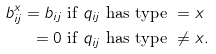<formula> <loc_0><loc_0><loc_500><loc_500>b ^ { x } _ { i j } = b _ { i j } & \text { if } q _ { i j } \text { has type } = x \\ = 0 & \text { if } q _ { i j } \text { has type } \neq x .</formula> 